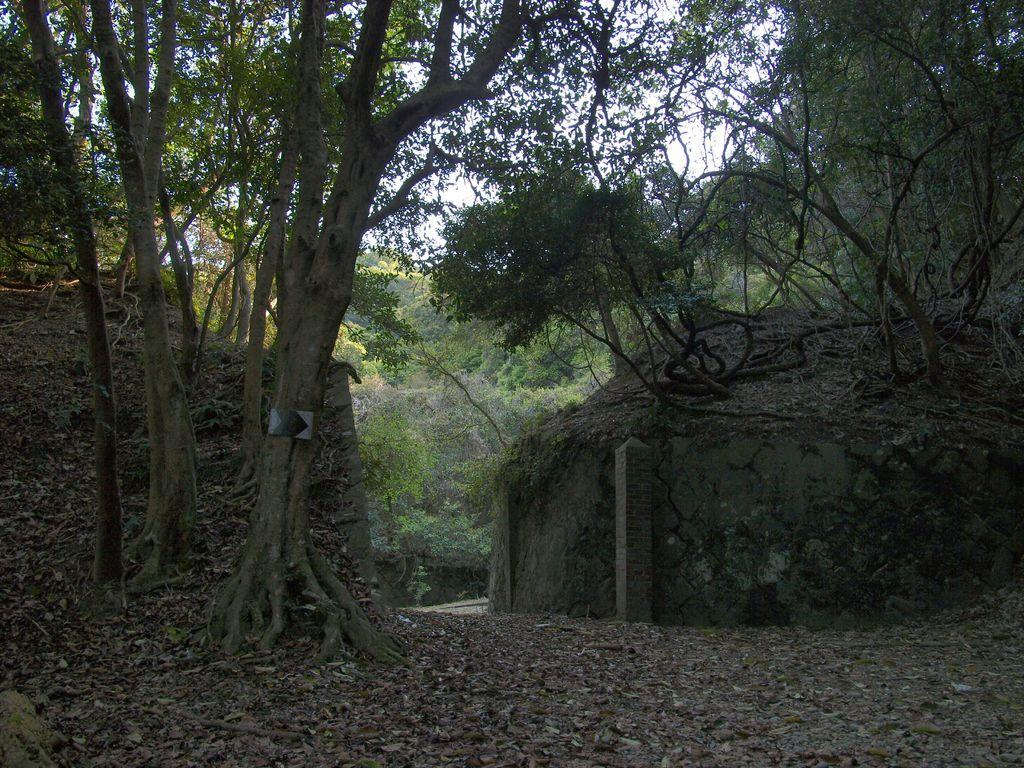What type of vegetation can be seen in the image? There are trees in the image. What type of structure is present in the image? There is a hut in the image. What is covering the ground in the image? Dry leaves are present on the ground in the image. Can you describe the digestion process of the ghost in the image? There is no ghost present in the image, so it is not possible to describe its digestion process. How many hens are visible in the image? There are no hens present in the image. 